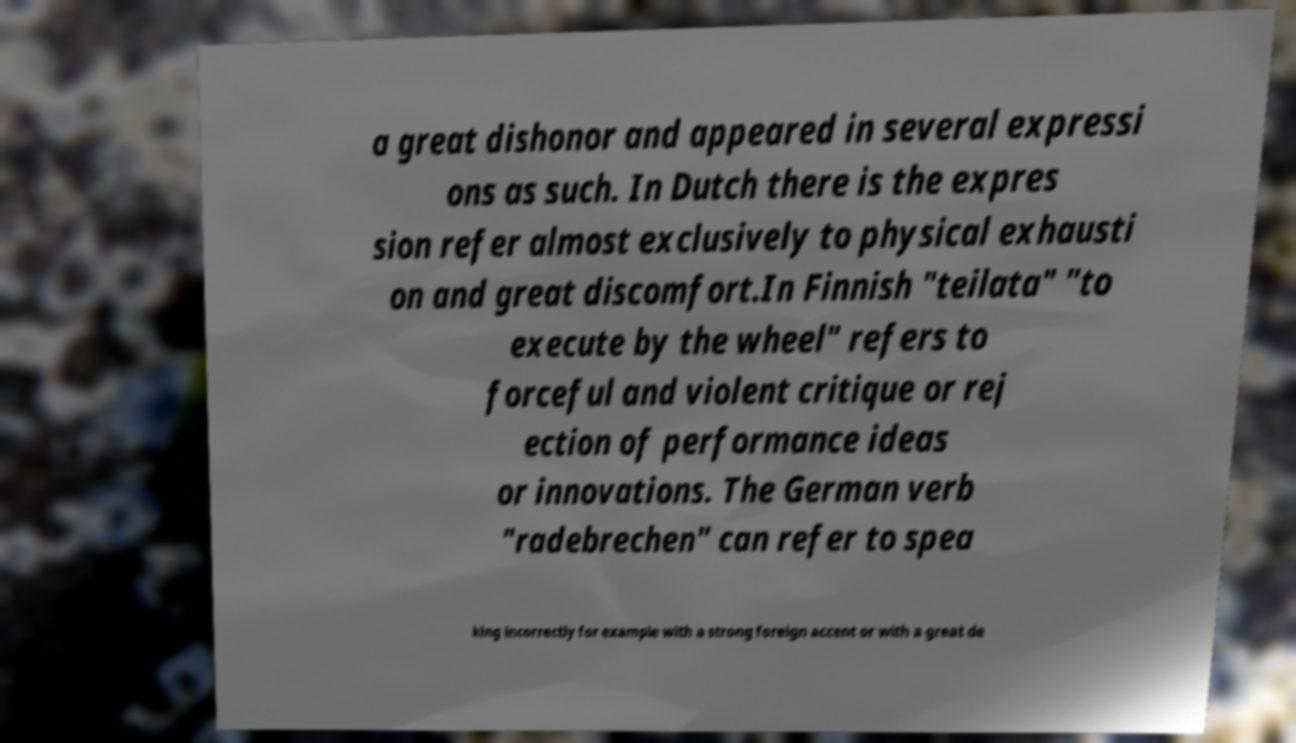There's text embedded in this image that I need extracted. Can you transcribe it verbatim? a great dishonor and appeared in several expressi ons as such. In Dutch there is the expres sion refer almost exclusively to physical exhausti on and great discomfort.In Finnish "teilata" "to execute by the wheel" refers to forceful and violent critique or rej ection of performance ideas or innovations. The German verb "radebrechen" can refer to spea king incorrectly for example with a strong foreign accent or with a great de 